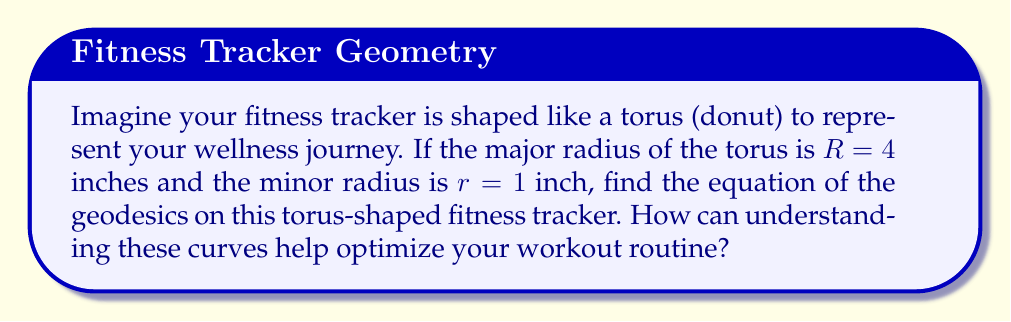Solve this math problem. To find the geodesics on a torus, we'll follow these steps:

1) The parametric equations of a torus are:
   $$x = (R + r\cos v)\cos u$$
   $$y = (R + r\cos v)\sin u$$
   $$z = r\sin v$$
   where $0 \leq u, v < 2\pi$

2) The geodesic equations on a torus are given by:
   $$\frac{d^2u}{ds^2} + \frac{2r\sin v}{R + r\cos v}\frac{du}{ds}\frac{dv}{ds} = 0$$
   $$\frac{d^2v}{ds^2} - (R + r\cos v)\cos v\left(\frac{du}{ds}\right)^2 + r\sin v\left(\frac{dv}{ds}\right)^2 = 0$$

3) These equations can be simplified to:
   $$\frac{d^2u}{ds^2} + \frac{2r\sin v}{R + r\cos v}\frac{du}{ds}\frac{dv}{ds} = 0$$
   $$\frac{d^2v}{ds^2} - (R + r\cos v)\cos v\left(\frac{du}{ds}\right)^2 + r\sin v\left(\frac{dv}{ds}\right)^2 = 0$$

4) Substituting the given values $R=4$ and $r=1$:
   $$\frac{d^2u}{ds^2} + \frac{2\sin v}{4 + \cos v}\frac{du}{ds}\frac{dv}{ds} = 0$$
   $$\frac{d^2v}{ds^2} - (4 + \cos v)\cos v\left(\frac{du}{ds}\right)^2 + \sin v\left(\frac{dv}{ds}\right)^2 = 0$$

Understanding these curves can help optimize workout routines by visualizing the most efficient paths on the fitness tracker, potentially leading to more effective calorie burning and step counting.
Answer: $$\frac{d^2u}{ds^2} + \frac{2\sin v}{4 + \cos v}\frac{du}{ds}\frac{dv}{ds} = 0$$
$$\frac{d^2v}{ds^2} - (4 + \cos v)\cos v\left(\frac{du}{ds}\right)^2 + \sin v\left(\frac{dv}{ds}\right)^2 = 0$$ 